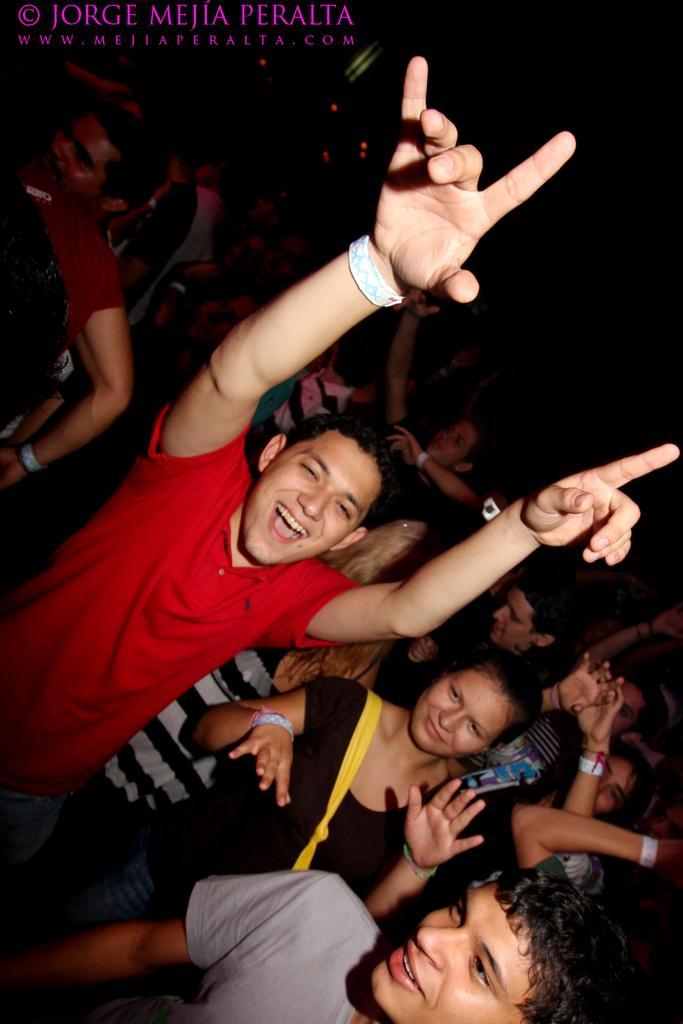In one or two sentences, can you explain what this image depicts? In this image there is a man in the middle who is wearing the red t-shirt has kept his two hands upwards. In the background there are so many people who are dancing. 